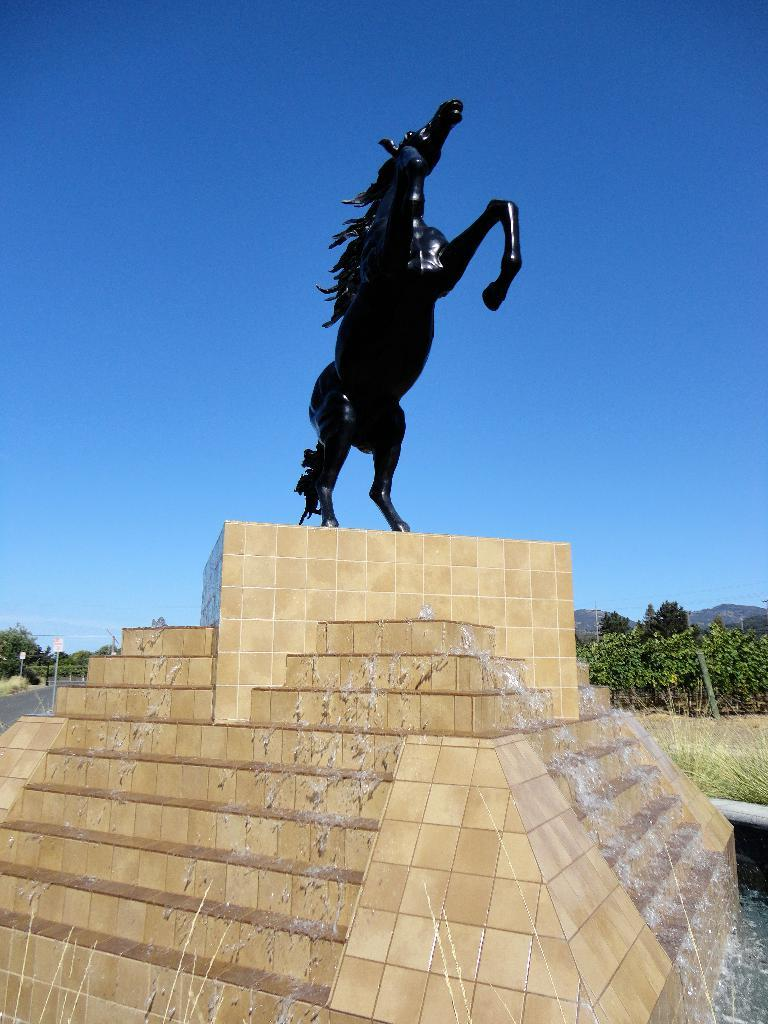What is the main subject of the image? There is a statue of a horse in the image. Where is the statue located? The statue is placed on a water fountain. What can be seen in the background of the image? There is a group of trees and mountains visible in the background of the image. What else is visible in the background of the image? The sky is visible in the background of the image. What type of muscle can be seen flexing in the image? There is no muscle visible in the image, as it features a statue of a horse. What type of bed is present in the image? There is no bed present in the image; it features a statue of a horse on a water fountain. 